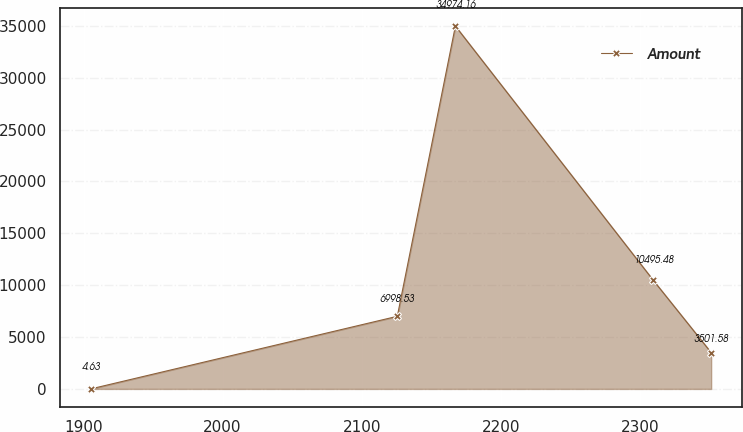Convert chart. <chart><loc_0><loc_0><loc_500><loc_500><line_chart><ecel><fcel>Amount<nl><fcel>1905.35<fcel>4.63<nl><fcel>2125.62<fcel>6998.53<nl><fcel>2167.38<fcel>34974.2<nl><fcel>2309.54<fcel>10495.5<nl><fcel>2351.3<fcel>3501.58<nl></chart> 